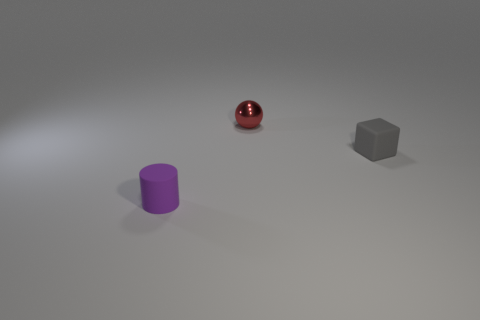Add 2 large cyan matte objects. How many objects exist? 5 Add 1 purple things. How many purple things exist? 2 Subtract 0 blue cubes. How many objects are left? 3 Subtract all spheres. How many objects are left? 2 Subtract all small cyan rubber objects. Subtract all purple matte cylinders. How many objects are left? 2 Add 2 tiny matte cylinders. How many tiny matte cylinders are left? 3 